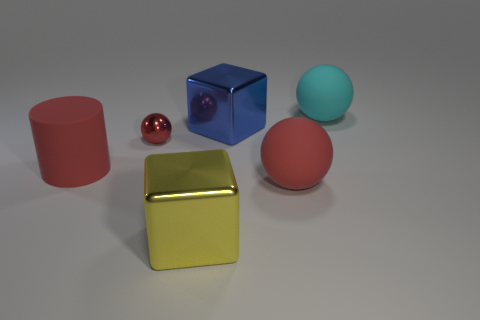Can you infer the material composition of the objects based on their appearance? Based on their appearance, the objects seem to be composed of different materials. The yellow cube appears to be metallic due to its reflective surface and crisp edges. The blue cube and red cylinder also seem to have some reflective qualities but are likely made of a high-gloss plastic given their less sharp reflections compared to the yellow cube. The small red sphere can be inferred as glass or a highly-polished stone, owing to its near-perfect mirror-like finish. Lastly, the pink sphere's non-reflective surface suggests a matte material, possibly rubber or a matte-finished plastic. 